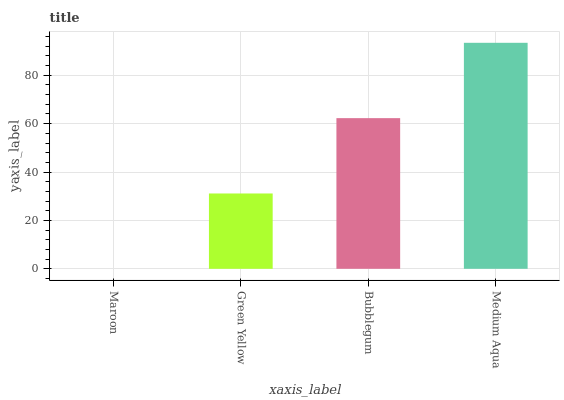Is Maroon the minimum?
Answer yes or no. Yes. Is Medium Aqua the maximum?
Answer yes or no. Yes. Is Green Yellow the minimum?
Answer yes or no. No. Is Green Yellow the maximum?
Answer yes or no. No. Is Green Yellow greater than Maroon?
Answer yes or no. Yes. Is Maroon less than Green Yellow?
Answer yes or no. Yes. Is Maroon greater than Green Yellow?
Answer yes or no. No. Is Green Yellow less than Maroon?
Answer yes or no. No. Is Bubblegum the high median?
Answer yes or no. Yes. Is Green Yellow the low median?
Answer yes or no. Yes. Is Maroon the high median?
Answer yes or no. No. Is Bubblegum the low median?
Answer yes or no. No. 